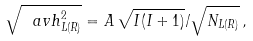Convert formula to latex. <formula><loc_0><loc_0><loc_500><loc_500>\sqrt { \ a v { h _ { L ( R ) } ^ { 2 } } } = A \, \sqrt { I ( I + 1 ) } / \sqrt { N _ { L ( R ) } } \, ,</formula> 